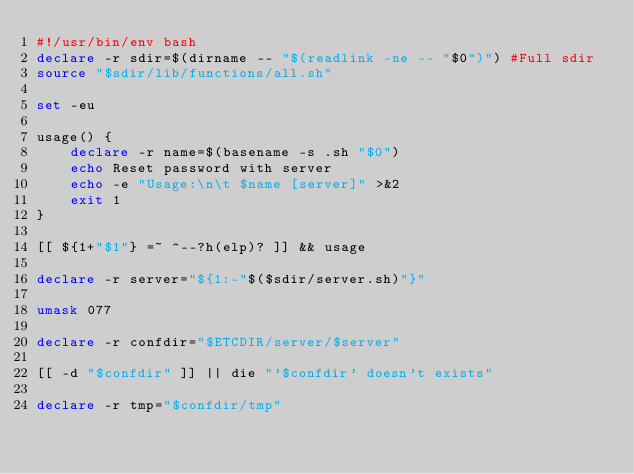Convert code to text. <code><loc_0><loc_0><loc_500><loc_500><_Bash_>#!/usr/bin/env bash
declare -r sdir=$(dirname -- "$(readlink -ne -- "$0")")	#Full sdir
source "$sdir/lib/functions/all.sh"

set -eu

usage() {
    declare -r name=$(basename -s .sh "$0")
    echo Reset password with server
    echo -e "Usage:\n\t $name [server]" >&2
    exit 1
}

[[ ${1+"$1"} =~ ^--?h(elp)? ]] && usage

declare -r server="${1:-"$($sdir/server.sh)"}"

umask 077

declare -r confdir="$ETCDIR/server/$server"

[[ -d "$confdir" ]] || die "'$confdir' doesn't exists"

declare -r tmp="$confdir/tmp"</code> 